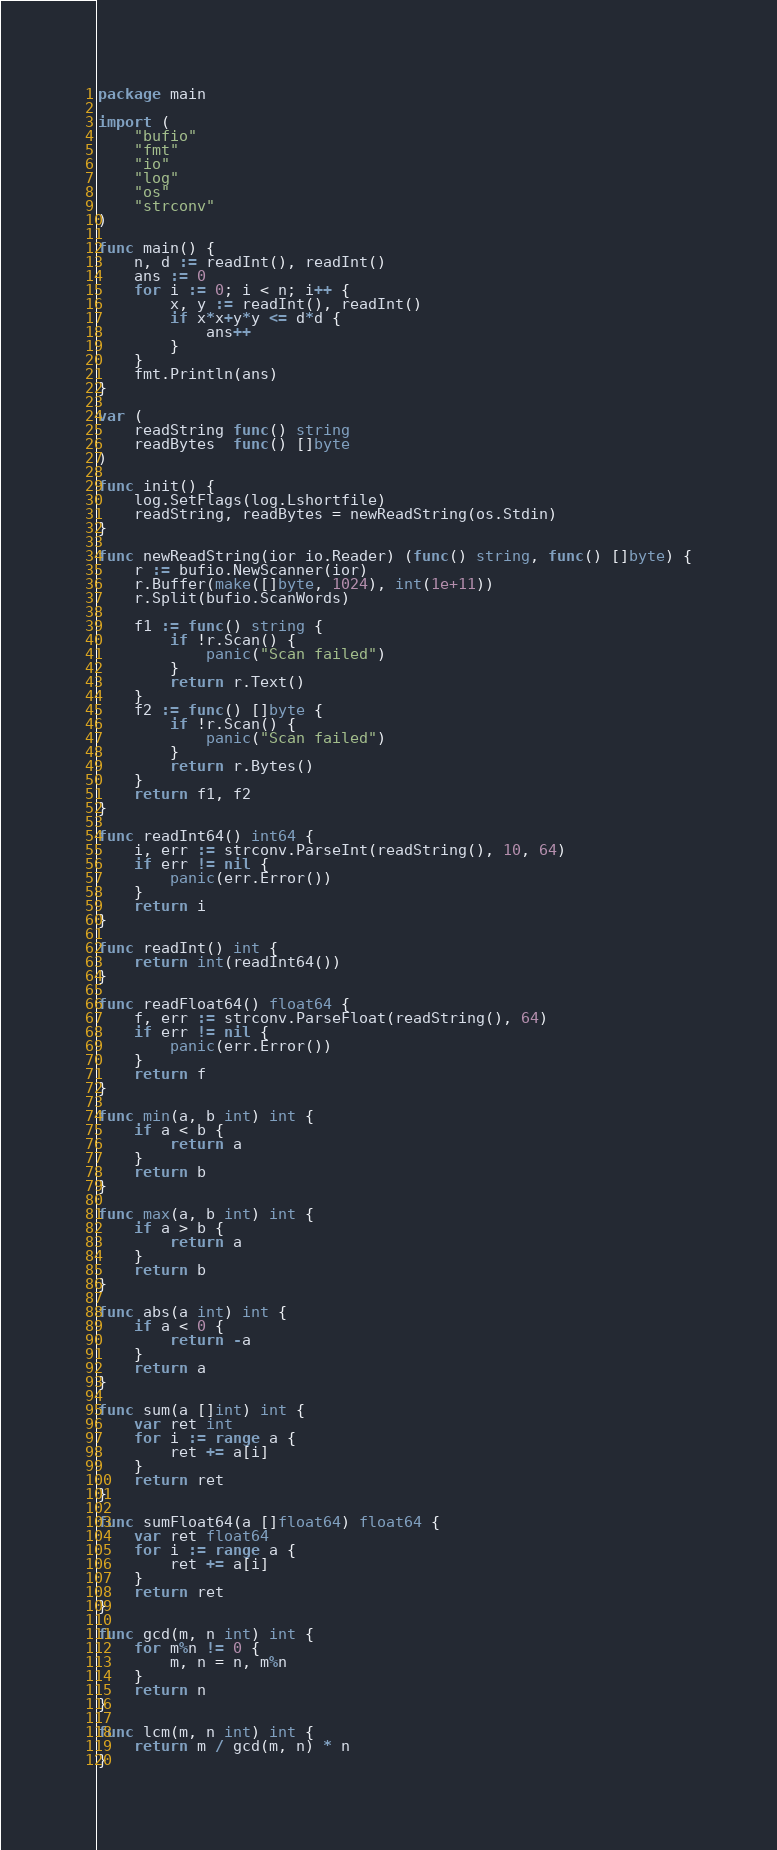Convert code to text. <code><loc_0><loc_0><loc_500><loc_500><_Go_>package main

import (
	"bufio"
	"fmt"
	"io"
	"log"
	"os"
	"strconv"
)

func main() {
	n, d := readInt(), readInt()
	ans := 0
	for i := 0; i < n; i++ {
		x, y := readInt(), readInt()
		if x*x+y*y <= d*d {
			ans++
		}
	}
	fmt.Println(ans)
}

var (
	readString func() string
	readBytes  func() []byte
)

func init() {
	log.SetFlags(log.Lshortfile)
	readString, readBytes = newReadString(os.Stdin)
}

func newReadString(ior io.Reader) (func() string, func() []byte) {
	r := bufio.NewScanner(ior)
	r.Buffer(make([]byte, 1024), int(1e+11))
	r.Split(bufio.ScanWords)

	f1 := func() string {
		if !r.Scan() {
			panic("Scan failed")
		}
		return r.Text()
	}
	f2 := func() []byte {
		if !r.Scan() {
			panic("Scan failed")
		}
		return r.Bytes()
	}
	return f1, f2
}

func readInt64() int64 {
	i, err := strconv.ParseInt(readString(), 10, 64)
	if err != nil {
		panic(err.Error())
	}
	return i
}

func readInt() int {
	return int(readInt64())
}

func readFloat64() float64 {
	f, err := strconv.ParseFloat(readString(), 64)
	if err != nil {
		panic(err.Error())
	}
	return f
}

func min(a, b int) int {
	if a < b {
		return a
	}
	return b
}

func max(a, b int) int {
	if a > b {
		return a
	}
	return b
}

func abs(a int) int {
	if a < 0 {
		return -a
	}
	return a
}

func sum(a []int) int {
	var ret int
	for i := range a {
		ret += a[i]
	}
	return ret
}

func sumFloat64(a []float64) float64 {
	var ret float64
	for i := range a {
		ret += a[i]
	}
	return ret
}

func gcd(m, n int) int {
	for m%n != 0 {
		m, n = n, m%n
	}
	return n
}

func lcm(m, n int) int {
	return m / gcd(m, n) * n
}
</code> 